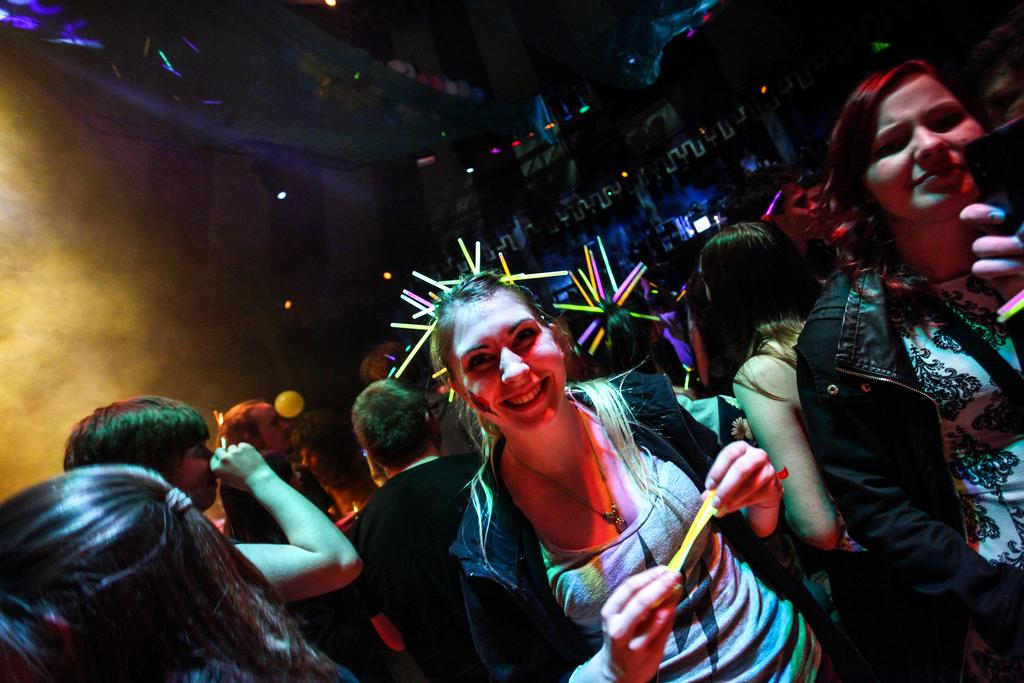What is happening in the image? There are people standing in the image. What are the people holding? The people are holding something. What can be seen in the background of the image? There is fog and lights visible in the background of the image. What type of farm can be seen in the background of the image? There is no farm present in the image; only fog and lights are visible in the background. 